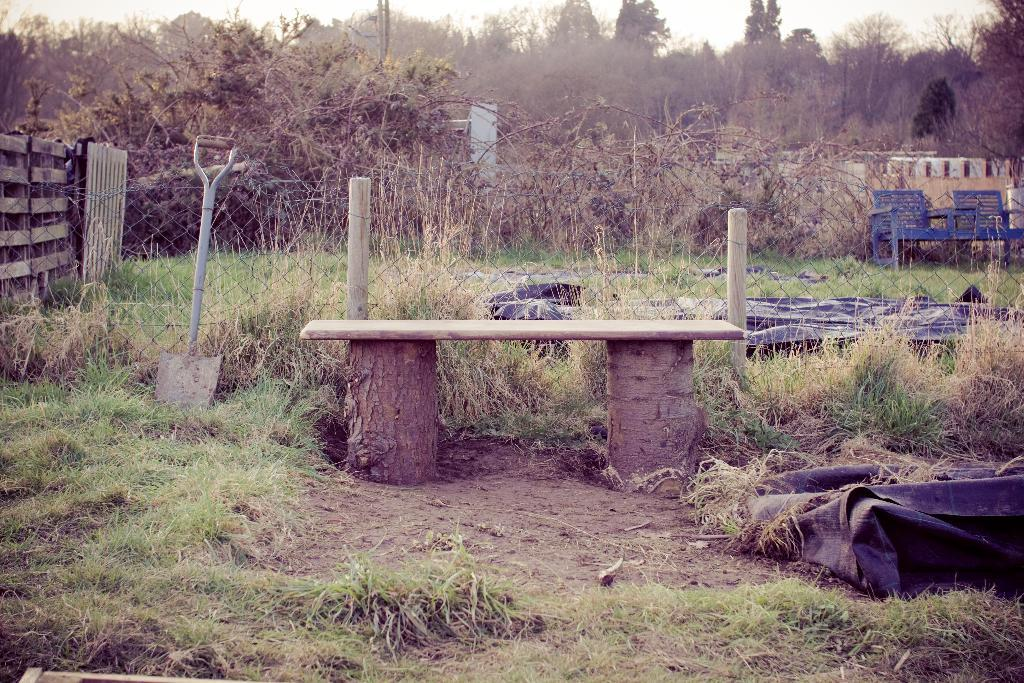What is the table in the image resting on? The table in the image is resting on tree trunks. What type of ground surface is visible in the image? There is grass visible in the image. What object can be used for a specific purpose in the image? There is a tool present in the image. What type of structure is visible in the image? There is a fence in the image. What color are the objects in the image? There are black objects in the image. What type of furniture is present in the image? There are chairs in the image. What type of living organisms are present in the image? There are plants in the image. What can be seen in the background of the image? There are trees and the sky visible in the background of the image. Where are the fairies hiding in the image? There are no fairies present in the image. What idea does the image represent? The image does not represent a specific idea; it is a visual representation of the mentioned objects and subjects. 